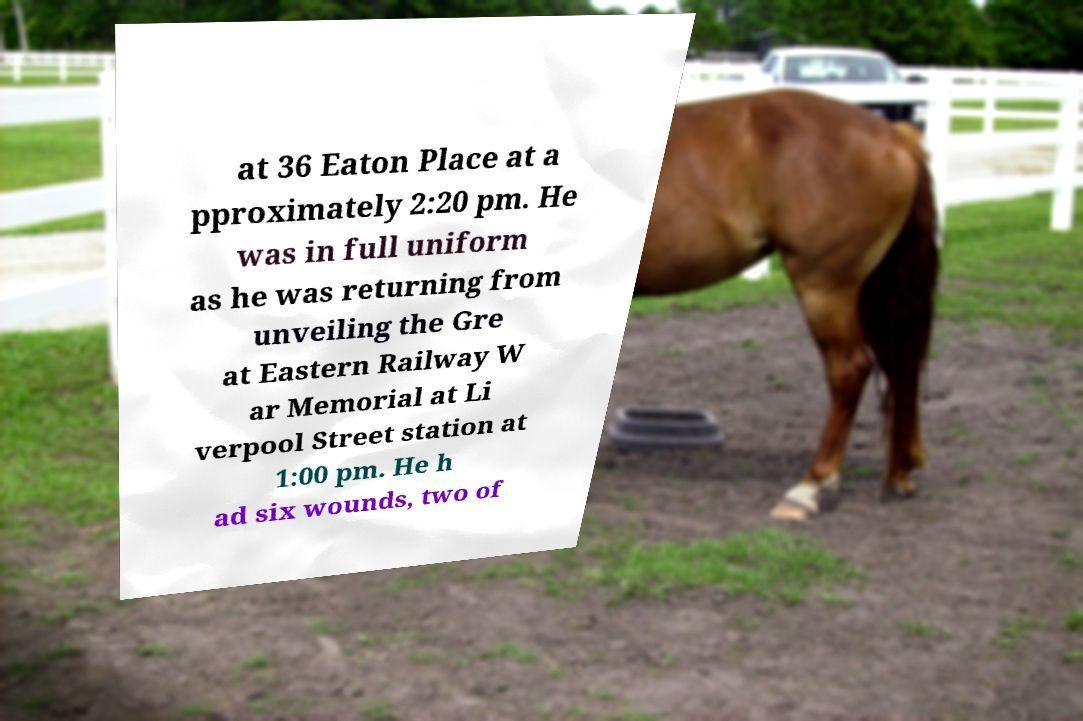Can you read and provide the text displayed in the image?This photo seems to have some interesting text. Can you extract and type it out for me? at 36 Eaton Place at a pproximately 2:20 pm. He was in full uniform as he was returning from unveiling the Gre at Eastern Railway W ar Memorial at Li verpool Street station at 1:00 pm. He h ad six wounds, two of 